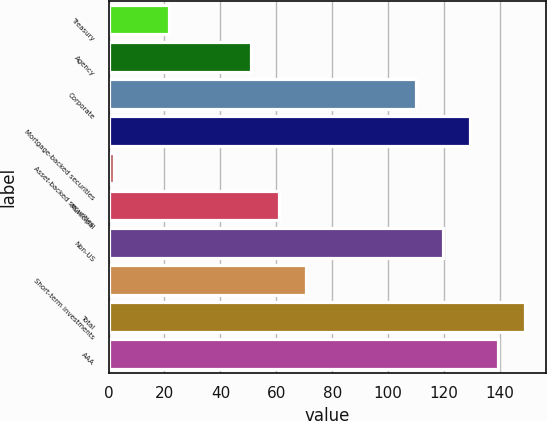Convert chart to OTSL. <chart><loc_0><loc_0><loc_500><loc_500><bar_chart><fcel>Treasury<fcel>Agency<fcel>Corporate<fcel>Mortgage-backed securities<fcel>Asset-backed securities<fcel>Municipal<fcel>Non-US<fcel>Short-term investments<fcel>Total<fcel>AAA<nl><fcel>21.6<fcel>51<fcel>109.8<fcel>129.4<fcel>2<fcel>60.8<fcel>119.6<fcel>70.6<fcel>149<fcel>139.2<nl></chart> 